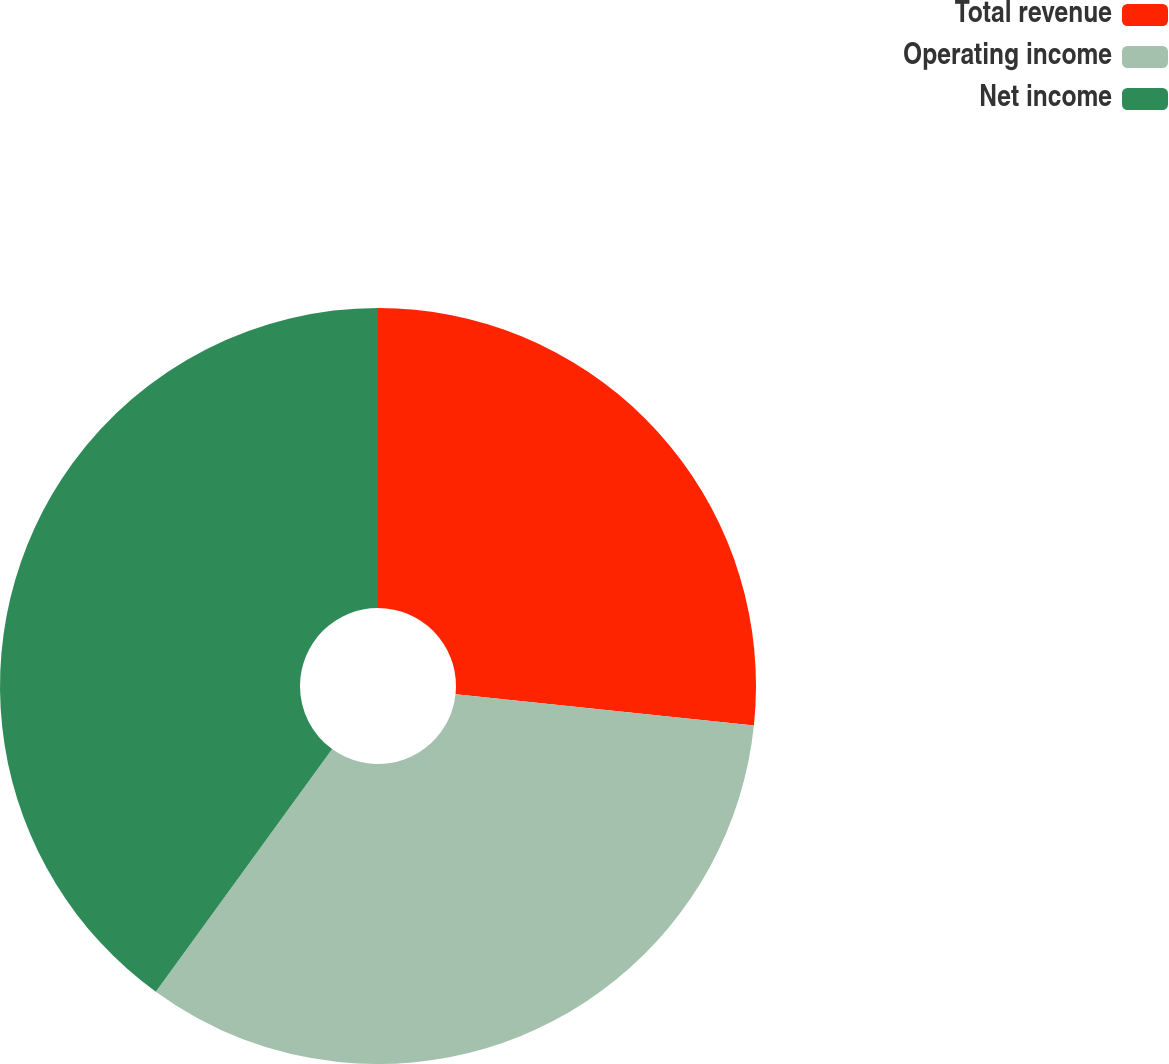Convert chart to OTSL. <chart><loc_0><loc_0><loc_500><loc_500><pie_chart><fcel>Total revenue<fcel>Operating income<fcel>Net income<nl><fcel>26.67%<fcel>33.33%<fcel>40.0%<nl></chart> 